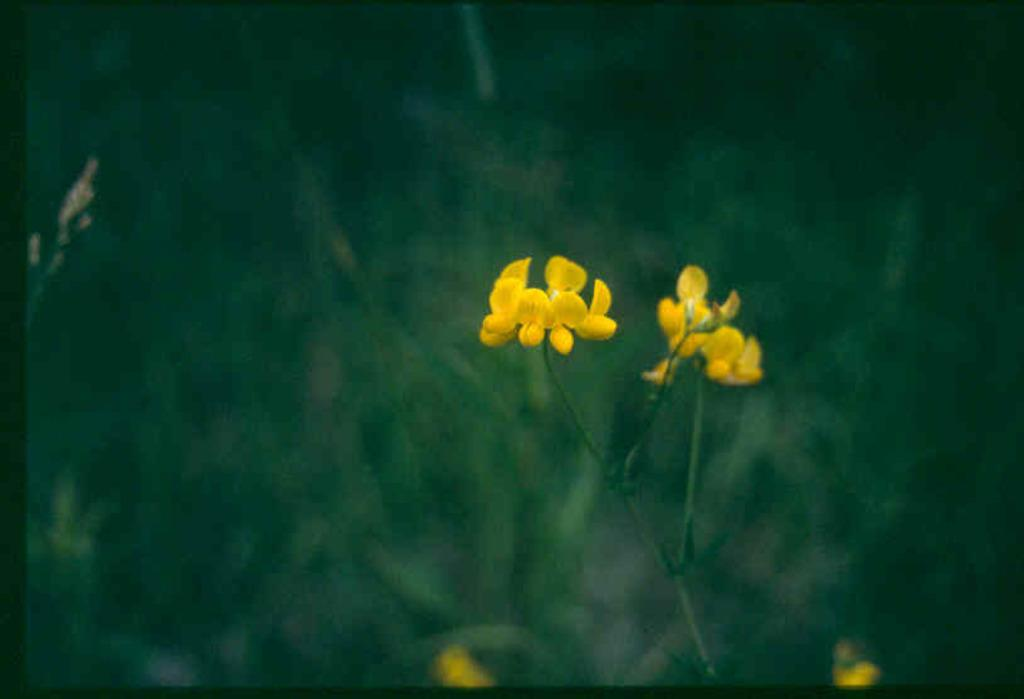What type of plant is featured in the image? There is a plant with yellow flowers in the image. Are there any other plants visible in the image? There are other plants in the background of the image, but they are not clearly visible. What time of day is depicted in the image? The time of day is not mentioned or depicted in the image. What type of furniture is present in the image? There is no furniture present in the image; it features a plant with yellow flowers and other plants in the background. 